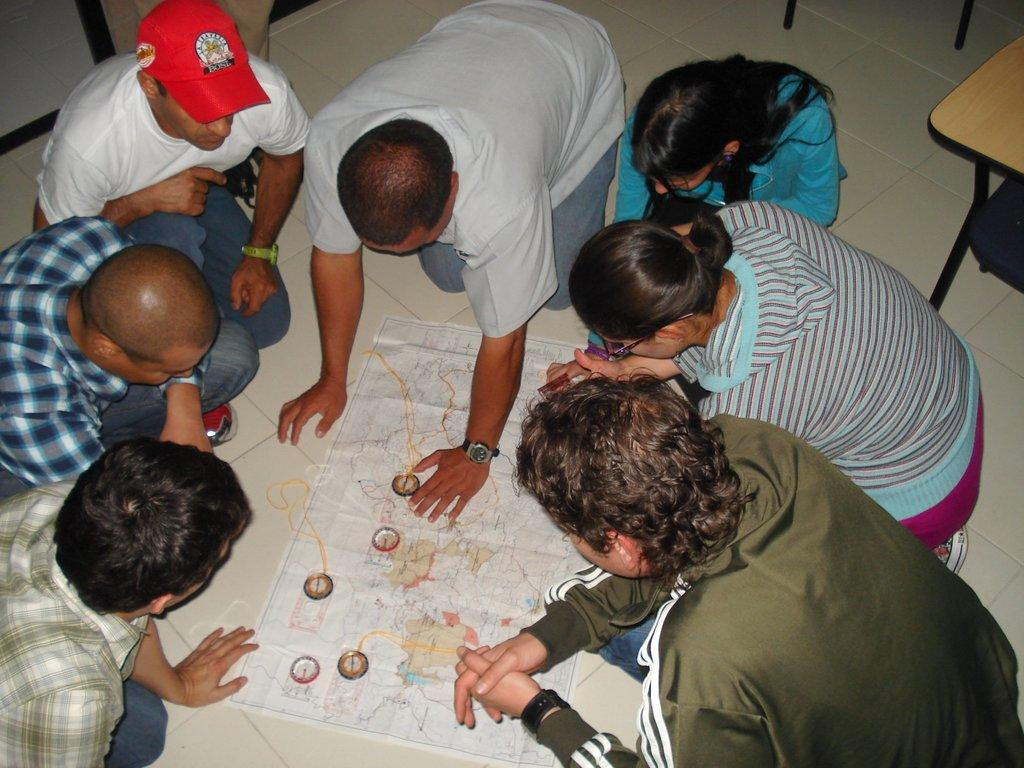What is on the floor in the image? There is a map on the floor. What is happening around the map? There are many people around the map. Can you describe the appearance of a person in the image? A person in the top left corner of the image is wearing a cap. What type of can is visible in the image? There is no can present in the image. What is the source of pleasure for the people around the map? The provided facts do not mention any source of pleasure for the people around the map. 